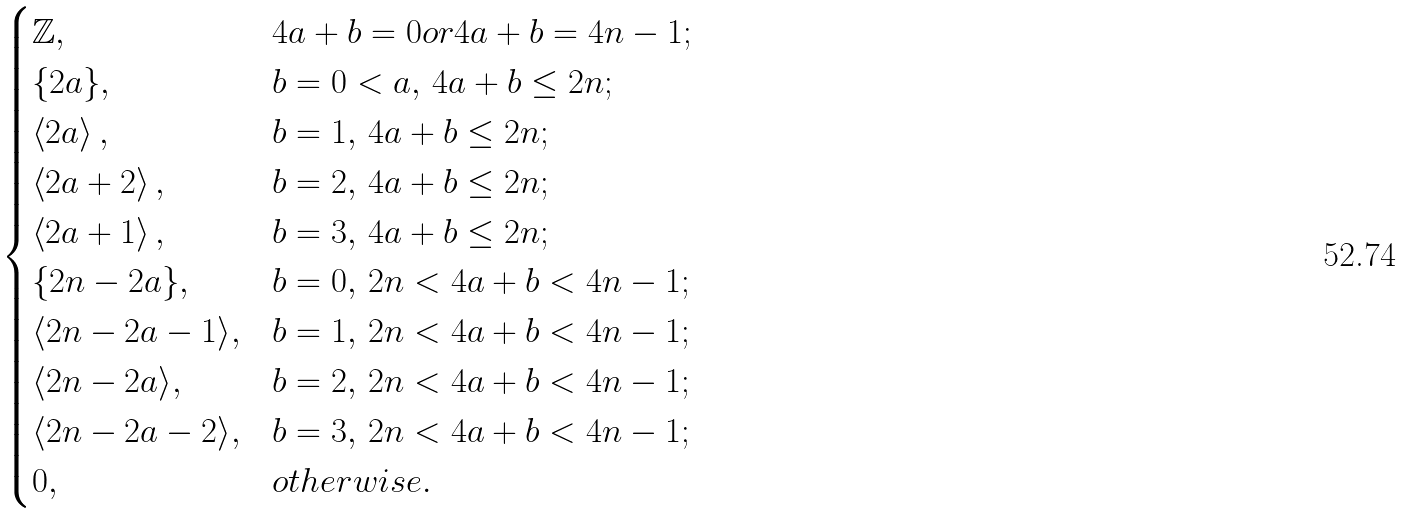<formula> <loc_0><loc_0><loc_500><loc_500>\begin{cases} \mathbb { Z } , & 4 a + b = 0 o r 4 a + b = 4 n - 1 ; \\ \{ 2 a \} , & b = 0 < a , \, 4 a + b \leq 2 n ; \\ \left \langle 2 a \right \rangle , & b = 1 , \, 4 a + b \leq 2 n ; \\ \left \langle 2 a + 2 \right \rangle , & b = 2 , \, 4 a + b \leq 2 n ; \\ \left \langle 2 a + 1 \right \rangle , & b = 3 , \, 4 a + b \leq 2 n ; \\ \{ 2 n - 2 a \} , & b = 0 , \, 2 n < 4 a + b < 4 n - 1 ; \\ \langle 2 n - 2 a - 1 \rangle , & b = 1 , \, 2 n < 4 a + b < 4 n - 1 ; \\ \langle 2 n - 2 a \rangle , & b = 2 , \, 2 n < 4 a + b < 4 n - 1 ; \\ \langle 2 n - 2 a - 2 \rangle , & b = 3 , \, 2 n < 4 a + b < 4 n - 1 ; \\ 0 , & o t h e r w i s e . \end{cases}</formula> 